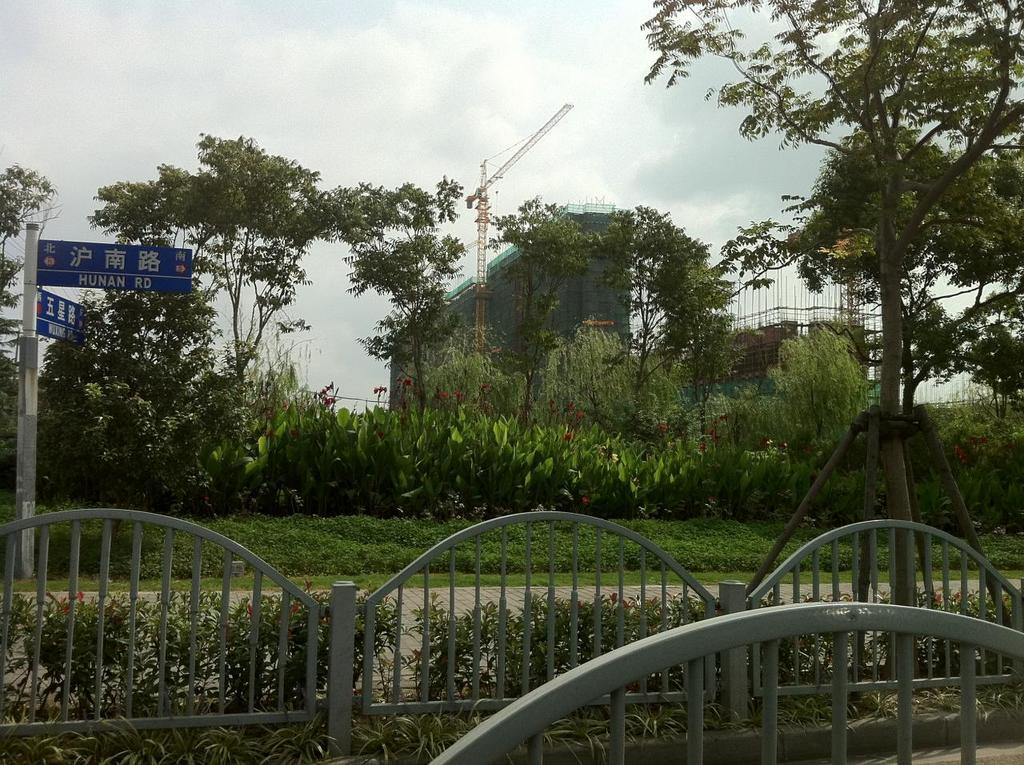What type of structures can be seen in the image? There are buildings in the image. What equipment is present in the image that is related to construction? Construction cranes are present in the image. What type of barriers can be seen in the image? Fences are visible in the image. What type of vegetation is present in the image? Plants, shrubs, bushes, and trees are visible in the image. What type of signage is present in the image? Sign boards are present in the image. What part of the natural environment is visible in the image? The sky is visible in the image. What type of weather can be inferred from the image? Clouds are present in the sky, suggesting a partly cloudy day. Can you tell me how many robins are perched on the construction cranes in the image? There are no robins present in the image; it features buildings, construction cranes, fences, plants, shrubs, bushes, trees, sign boards, and the sky. What role does the actor play in the construction process depicted in the image? There is no actor present in the image; it focuses on the construction site and its surroundings. 